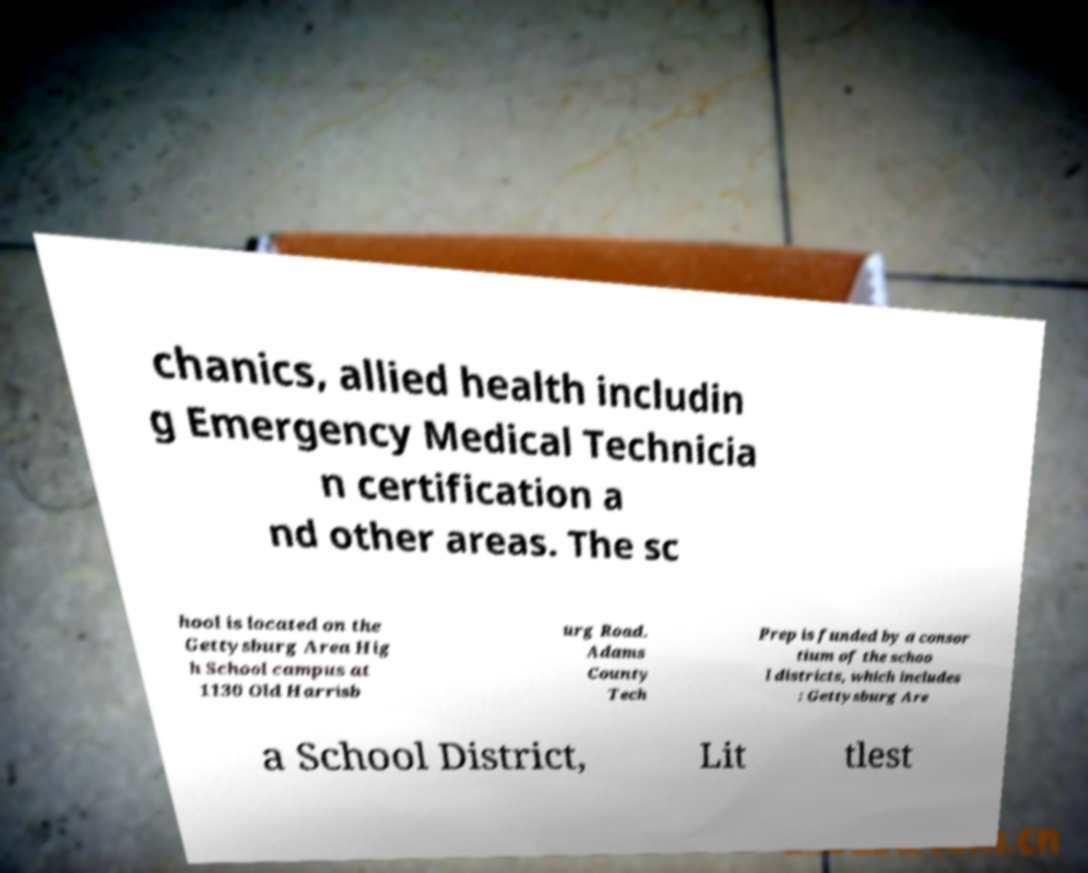Could you extract and type out the text from this image? chanics, allied health includin g Emergency Medical Technicia n certification a nd other areas. The sc hool is located on the Gettysburg Area Hig h School campus at 1130 Old Harrisb urg Road. Adams County Tech Prep is funded by a consor tium of the schoo l districts, which includes : Gettysburg Are a School District, Lit tlest 